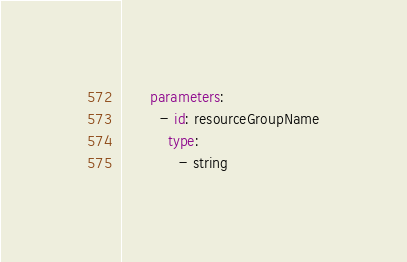<code> <loc_0><loc_0><loc_500><loc_500><_YAML_>      parameters:
        - id: resourceGroupName
          type:
            - string</code> 